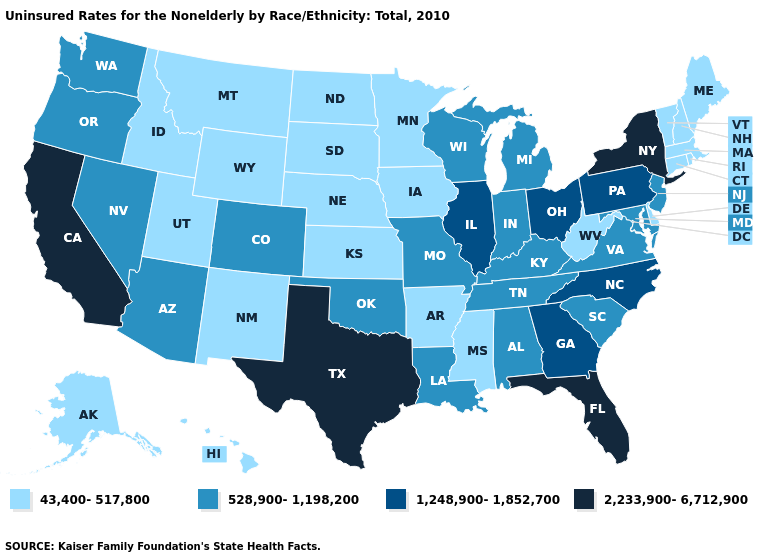Name the states that have a value in the range 43,400-517,800?
Answer briefly. Alaska, Arkansas, Connecticut, Delaware, Hawaii, Idaho, Iowa, Kansas, Maine, Massachusetts, Minnesota, Mississippi, Montana, Nebraska, New Hampshire, New Mexico, North Dakota, Rhode Island, South Dakota, Utah, Vermont, West Virginia, Wyoming. Name the states that have a value in the range 2,233,900-6,712,900?
Short answer required. California, Florida, New York, Texas. What is the value of Minnesota?
Write a very short answer. 43,400-517,800. What is the highest value in the MidWest ?
Give a very brief answer. 1,248,900-1,852,700. Does South Dakota have the same value as New York?
Short answer required. No. Name the states that have a value in the range 43,400-517,800?
Be succinct. Alaska, Arkansas, Connecticut, Delaware, Hawaii, Idaho, Iowa, Kansas, Maine, Massachusetts, Minnesota, Mississippi, Montana, Nebraska, New Hampshire, New Mexico, North Dakota, Rhode Island, South Dakota, Utah, Vermont, West Virginia, Wyoming. Does the map have missing data?
Short answer required. No. Does Washington have the same value as Nevada?
Keep it brief. Yes. What is the highest value in the Northeast ?
Short answer required. 2,233,900-6,712,900. Name the states that have a value in the range 528,900-1,198,200?
Answer briefly. Alabama, Arizona, Colorado, Indiana, Kentucky, Louisiana, Maryland, Michigan, Missouri, Nevada, New Jersey, Oklahoma, Oregon, South Carolina, Tennessee, Virginia, Washington, Wisconsin. How many symbols are there in the legend?
Quick response, please. 4. What is the value of Tennessee?
Quick response, please. 528,900-1,198,200. Which states have the lowest value in the South?
Quick response, please. Arkansas, Delaware, Mississippi, West Virginia. Which states have the lowest value in the USA?
Give a very brief answer. Alaska, Arkansas, Connecticut, Delaware, Hawaii, Idaho, Iowa, Kansas, Maine, Massachusetts, Minnesota, Mississippi, Montana, Nebraska, New Hampshire, New Mexico, North Dakota, Rhode Island, South Dakota, Utah, Vermont, West Virginia, Wyoming. Name the states that have a value in the range 528,900-1,198,200?
Write a very short answer. Alabama, Arizona, Colorado, Indiana, Kentucky, Louisiana, Maryland, Michigan, Missouri, Nevada, New Jersey, Oklahoma, Oregon, South Carolina, Tennessee, Virginia, Washington, Wisconsin. 